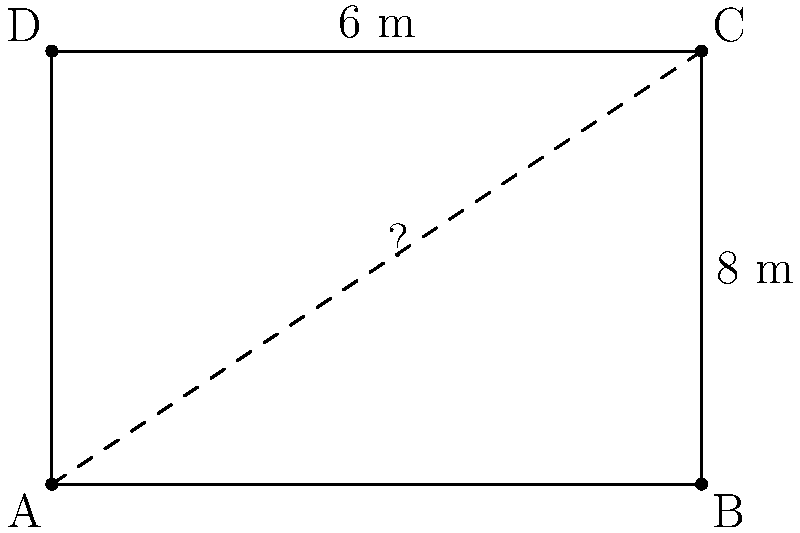At the local market in Mar'ivka, you notice a rectangular stall. The stall's length is 8 meters and its width is 6 meters. What is the length of the diagonal from one corner to the opposite corner of the stall? To find the diagonal length of the rectangular stall, we can use the Pythagorean theorem. Here's how:

1) Let's denote the diagonal as $d$, the length as $l$, and the width as $w$.

2) According to the Pythagorean theorem: $d^2 = l^2 + w^2$

3) We know that $l = 8$ meters and $w = 6$ meters.

4) Let's substitute these values:
   $d^2 = 8^2 + 6^2$

5) Calculate the squares:
   $d^2 = 64 + 36$

6) Add the results:
   $d^2 = 100$

7) To find $d$, we need to take the square root of both sides:
   $d = \sqrt{100}$

8) Simplify:
   $d = 10$

Therefore, the diagonal length of the stall is 10 meters.
Answer: 10 meters 